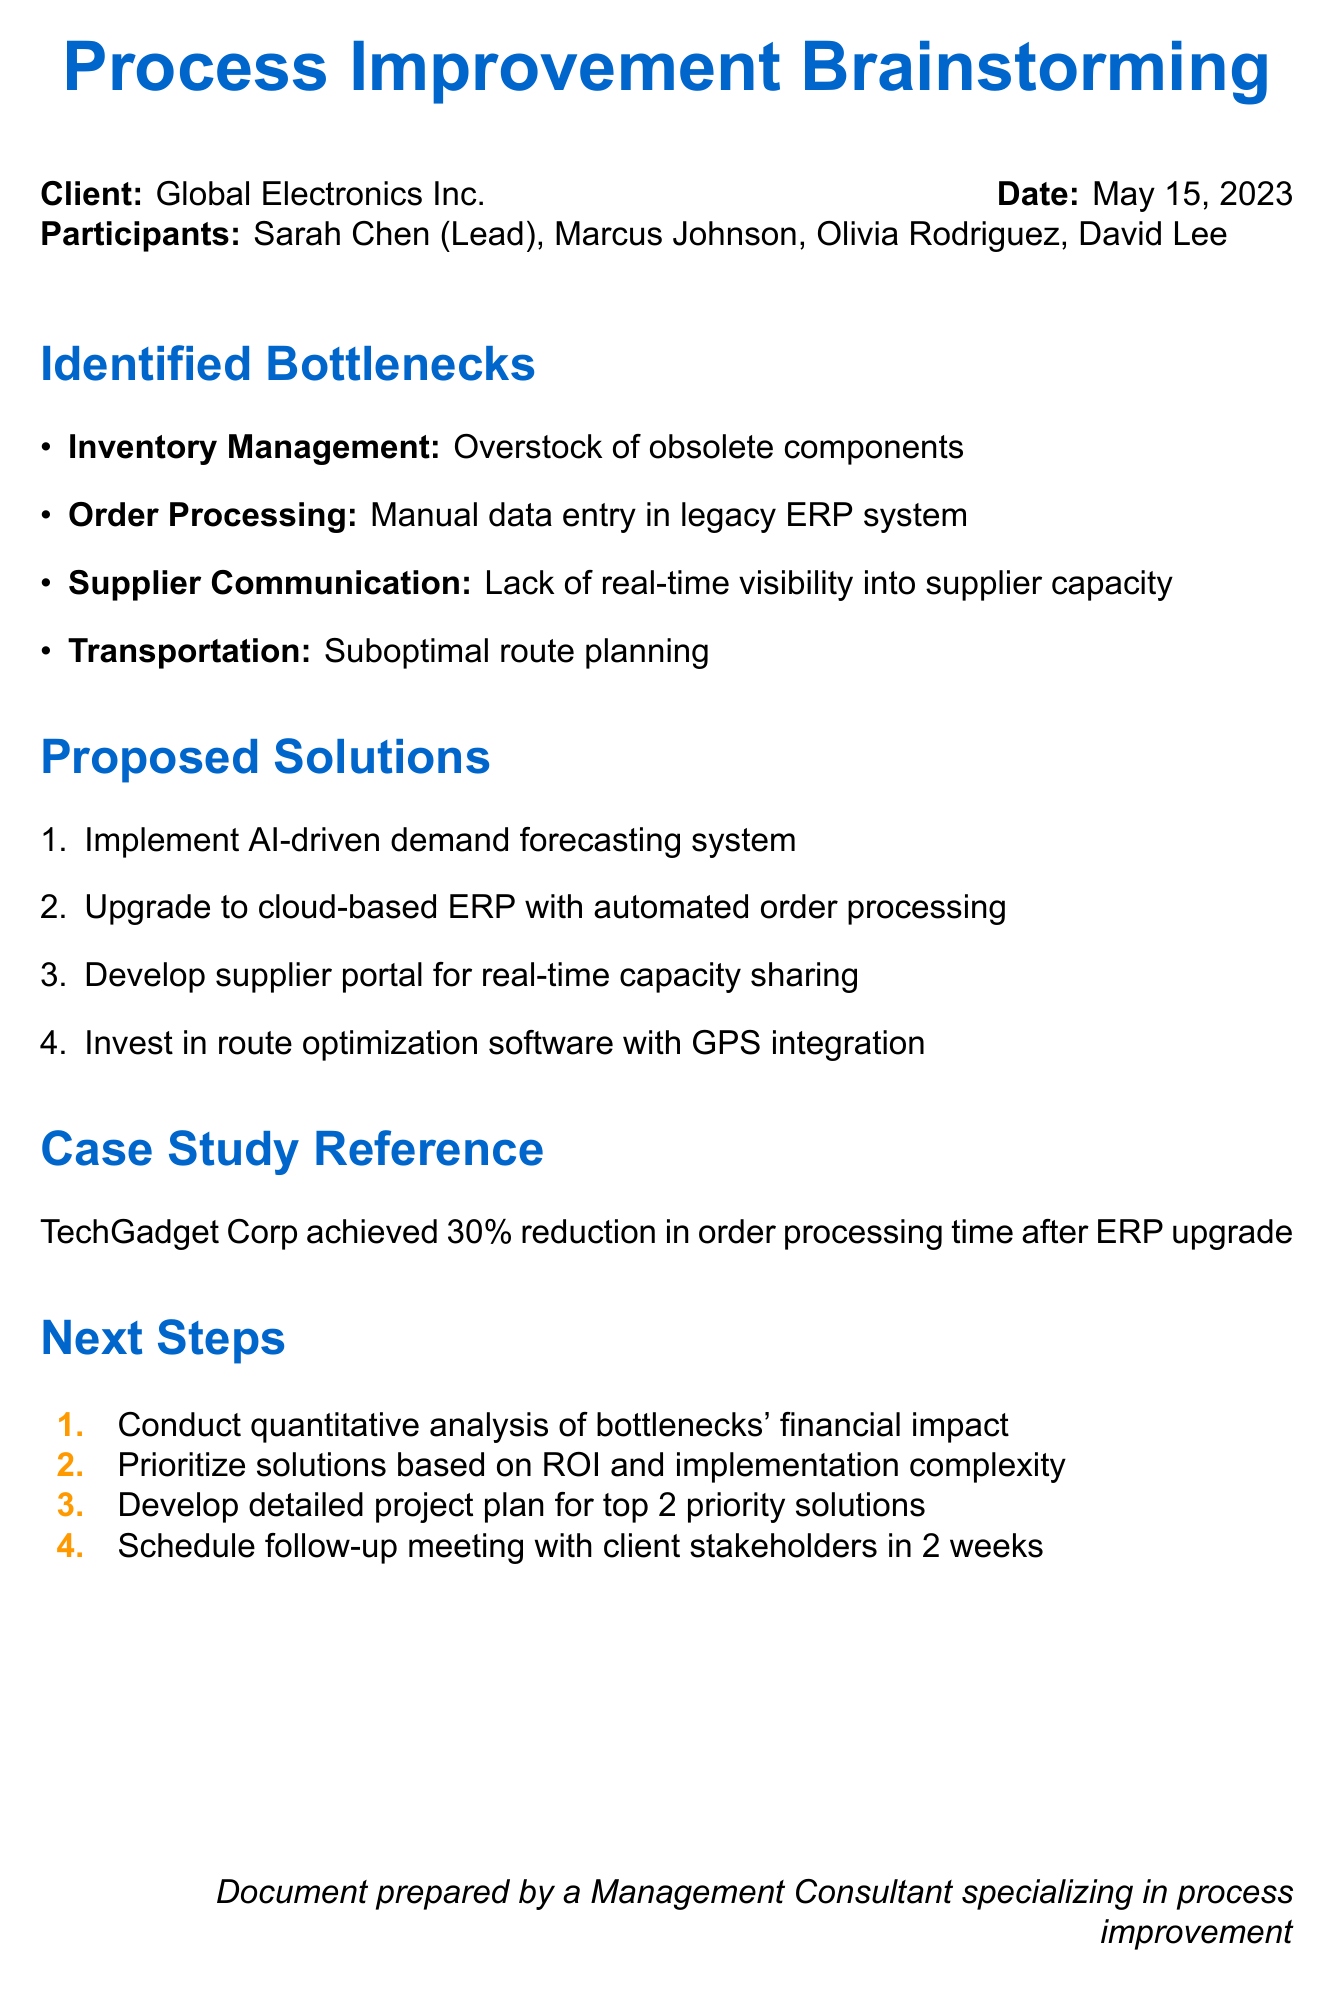What is the date of the brainstorming session? The date is mentioned at the start of the document details section.
Answer: May 15, 2023 Who is the lead consultant? The lead consultant's name is listed in the participant section of the document.
Answer: Sarah Chen What is one identified bottleneck in Inventory Management? The bottleneck in Inventory Management is specified under the identified bottlenecks section.
Answer: Overstock of obsolete components How much reduction in order processing time did TechGadget Corp achieve? The document refers to a case study that provides this specific improvement metric.
Answer: 30% What is one proposed solution for improving Order Processing? Solutions are outlined in a numbered list in the proposed solutions section.
Answer: Upgrade to cloud-based ERP with automated order processing What are the next steps to be taken after the brainstorming session? Next steps are listed in a tabular format towards the end of the document.
Answer: Conduct quantitative analysis of bottlenecks' financial impact What issue is associated with Supplier Communication? The identified issue in Supplier Communication is detailed in the identified bottlenecks section.
Answer: Lack of real-time visibility into supplier capacity Which participant represents the client? The client representative's name is noted in the participant section.
Answer: Olivia Rodriguez What impact is associated with suboptimal route planning? The impact is listed alongside the identified bottleneck in the transportation area.
Answer: Increased fuel costs and delayed deliveries 